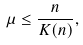Convert formula to latex. <formula><loc_0><loc_0><loc_500><loc_500>\mu \leq \frac { n } { K ( n ) } ,</formula> 